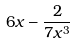Convert formula to latex. <formula><loc_0><loc_0><loc_500><loc_500>6 x - \frac { 2 } { 7 x ^ { 3 } }</formula> 